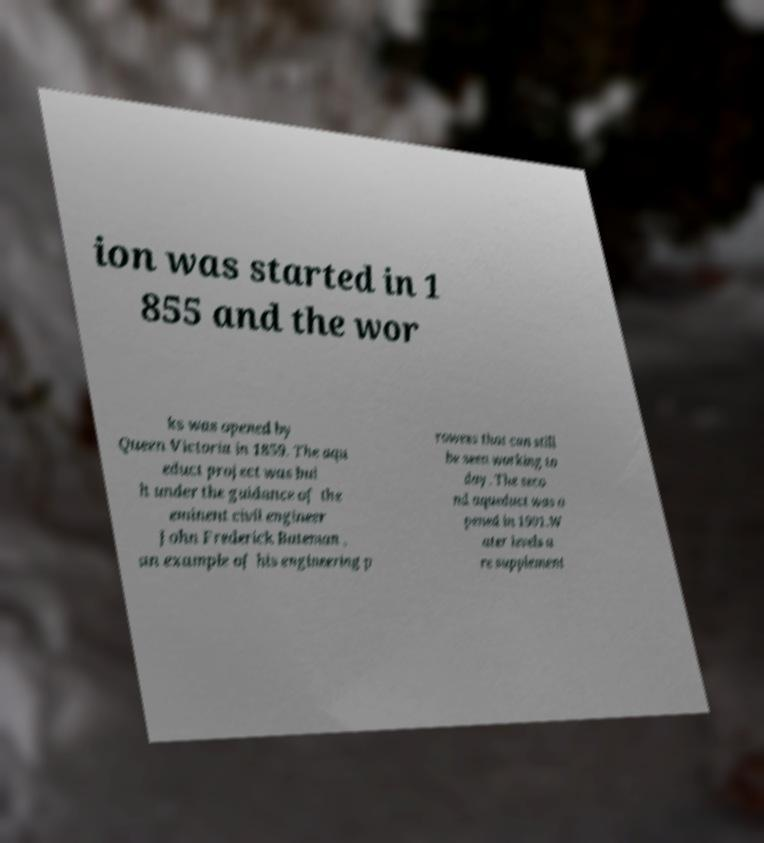Please read and relay the text visible in this image. What does it say? ion was started in 1 855 and the wor ks was opened by Queen Victoria in 1859. The aqu educt project was bui lt under the guidance of the eminent civil engineer John Frederick Bateman , an example of his engineering p rowess that can still be seen working to day. The seco nd aqueduct was o pened in 1901.W ater levels a re supplement 